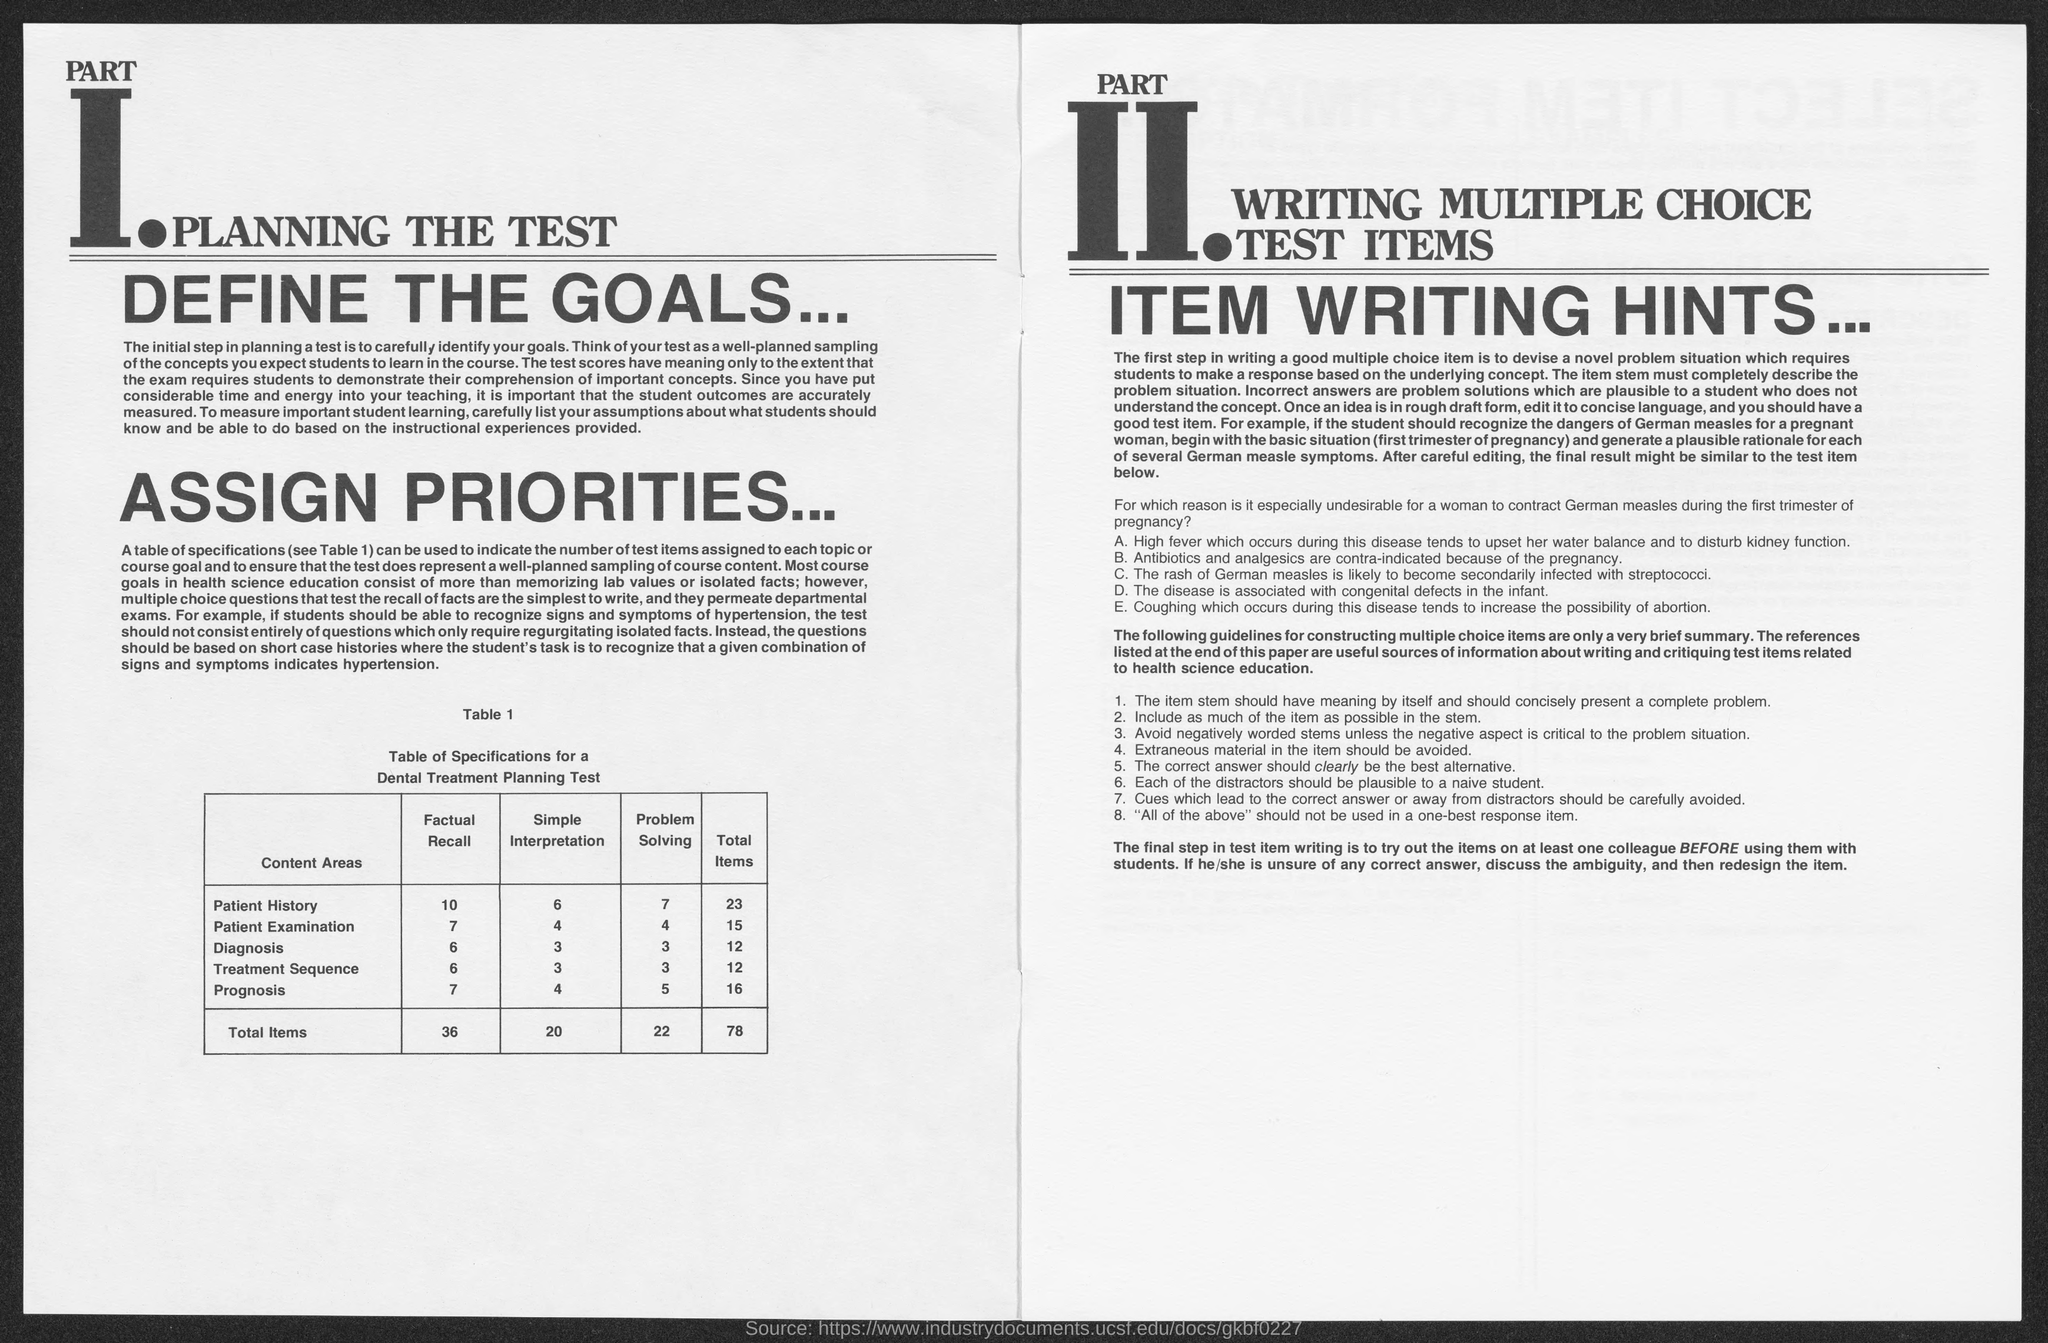What is the heading of part 1 as mentioned in the given page ?
Offer a very short reply. Planning the test. What is the value of total items in factual recall as mentioned in the given table ?
Provide a succinct answer. 36. What is the value of total items in simple interpretation as mentioned in the given table ?
Your answer should be compact. 20. What is the value of total items in problem solving as mentioned in the given table ?
Your response must be concise. 22. What is the value of total items in  diagnosis as mentioned in the given table ?
Your answer should be compact. 12. What is the value of total items for prognosis as mentioned in the given table ?
Provide a short and direct response. 16. What is the value of total items in treatment sequence as mentioned in the given table ?
Your response must be concise. 12. 